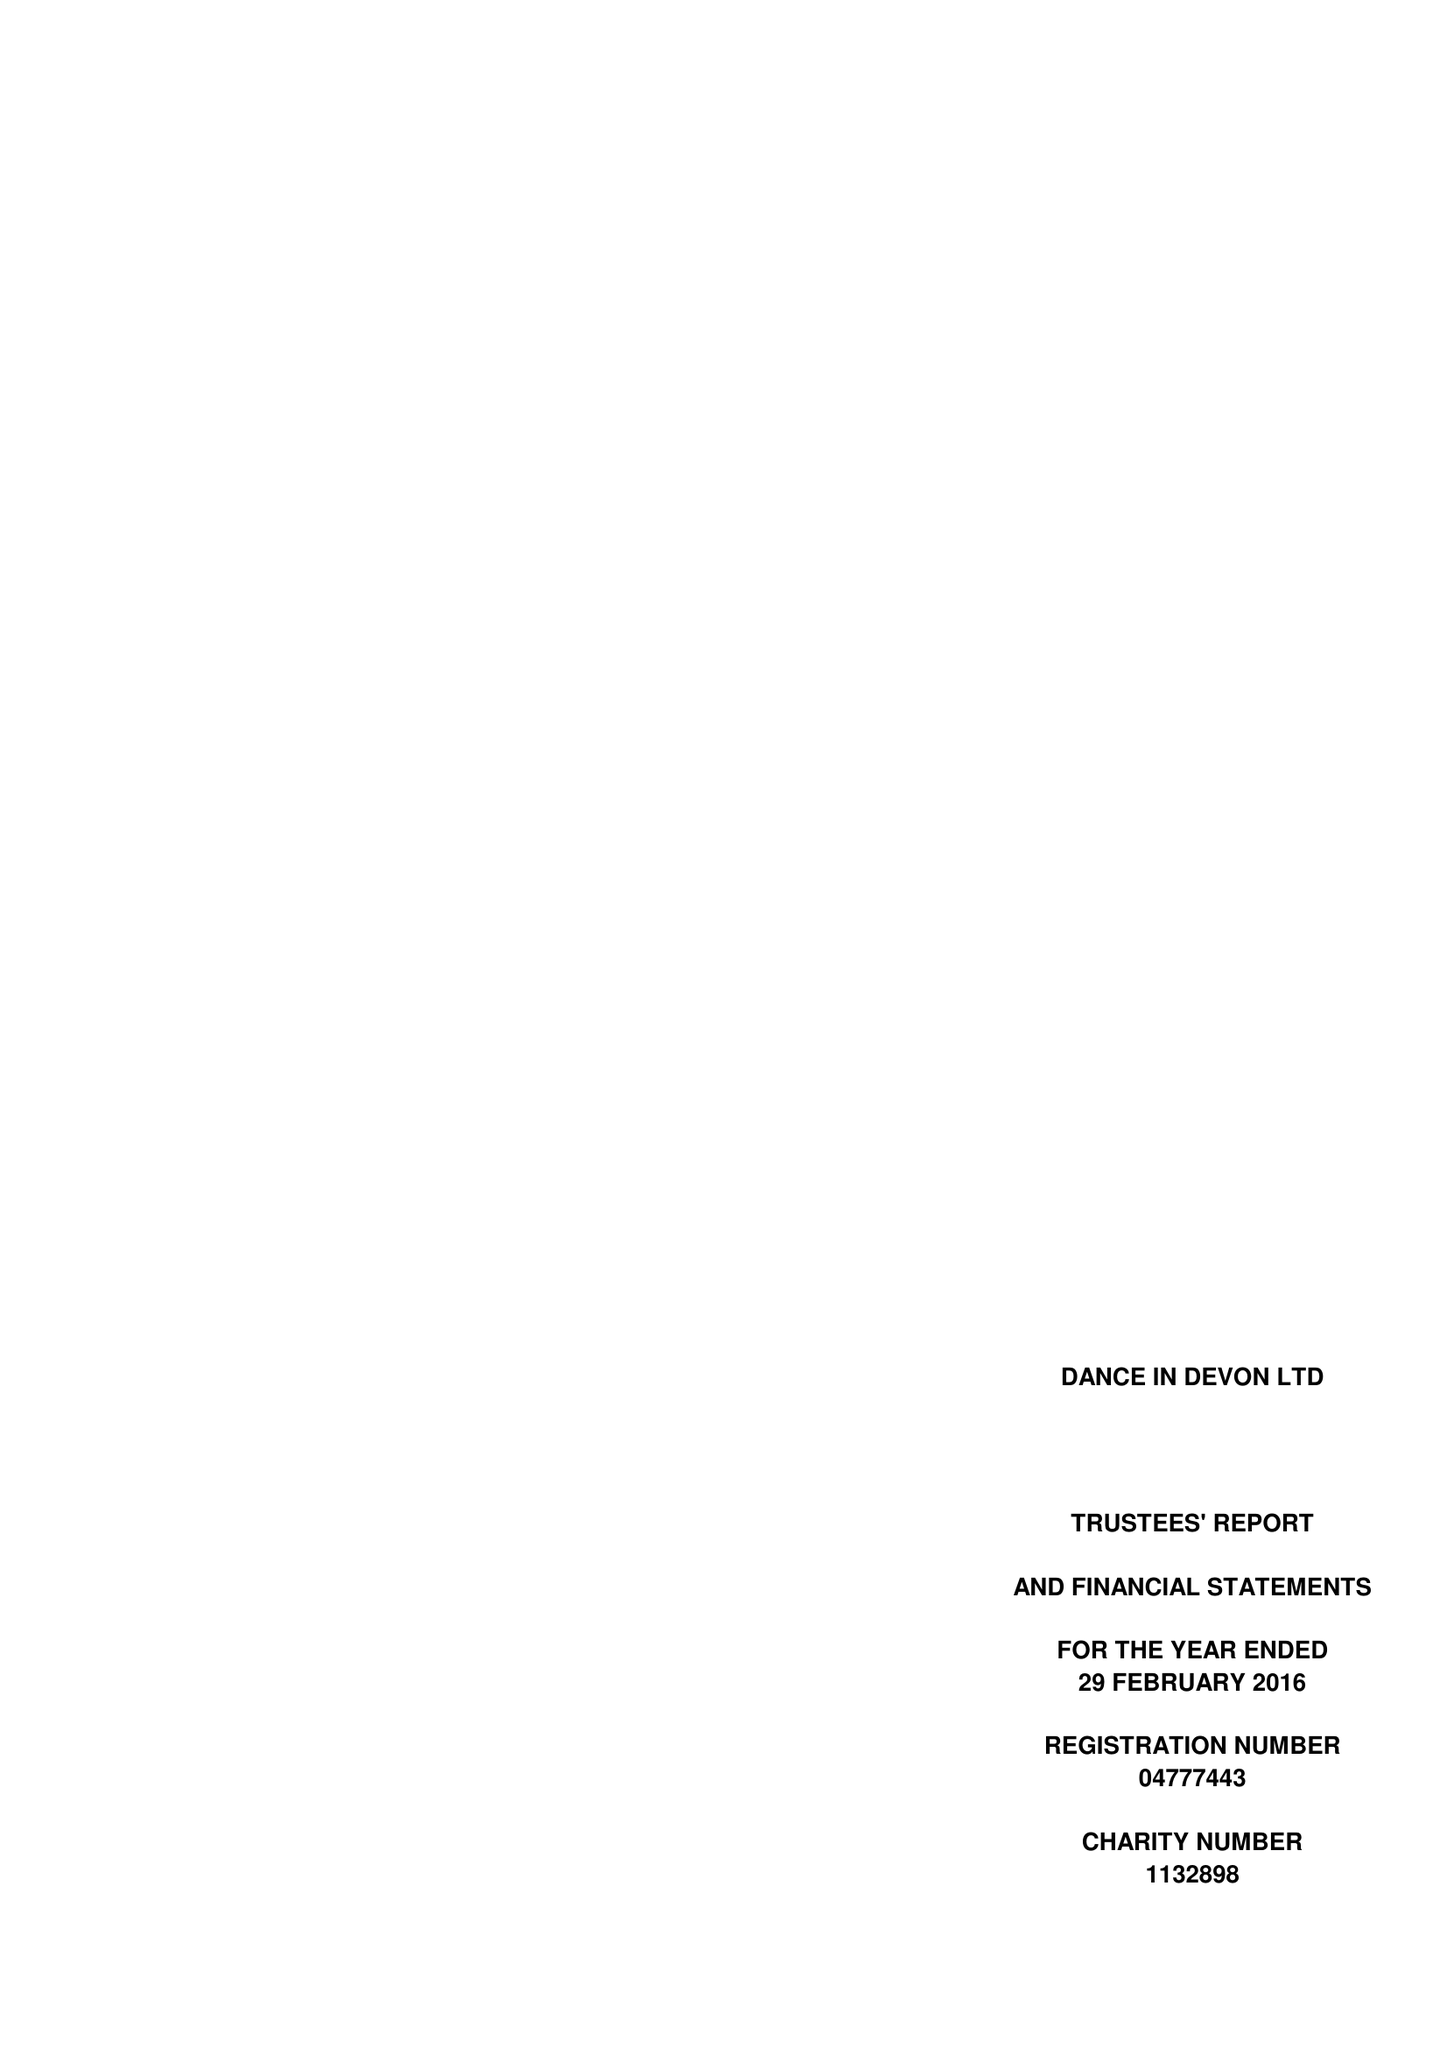What is the value for the income_annually_in_british_pounds?
Answer the question using a single word or phrase. 131540.00 